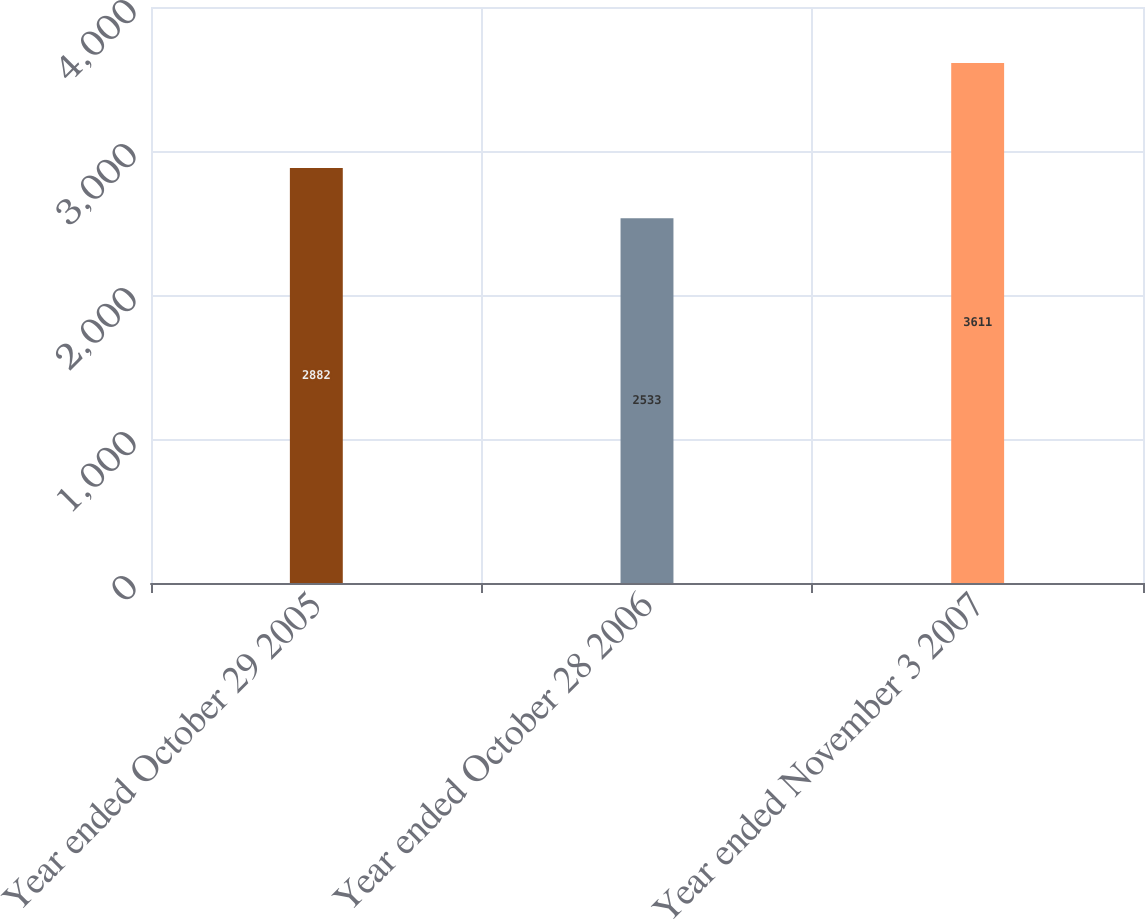<chart> <loc_0><loc_0><loc_500><loc_500><bar_chart><fcel>Year ended October 29 2005<fcel>Year ended October 28 2006<fcel>Year ended November 3 2007<nl><fcel>2882<fcel>2533<fcel>3611<nl></chart> 